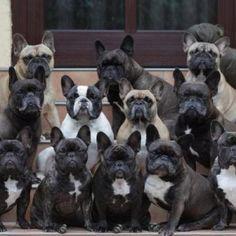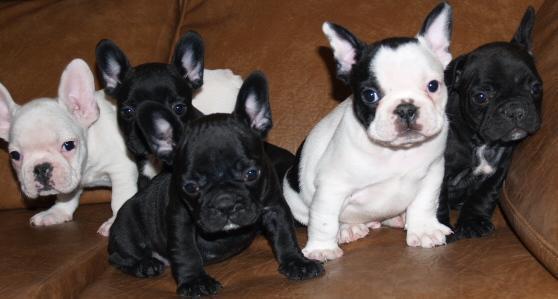The first image is the image on the left, the second image is the image on the right. Assess this claim about the two images: "There is exactly one dog in one of the images.". Correct or not? Answer yes or no. No. 